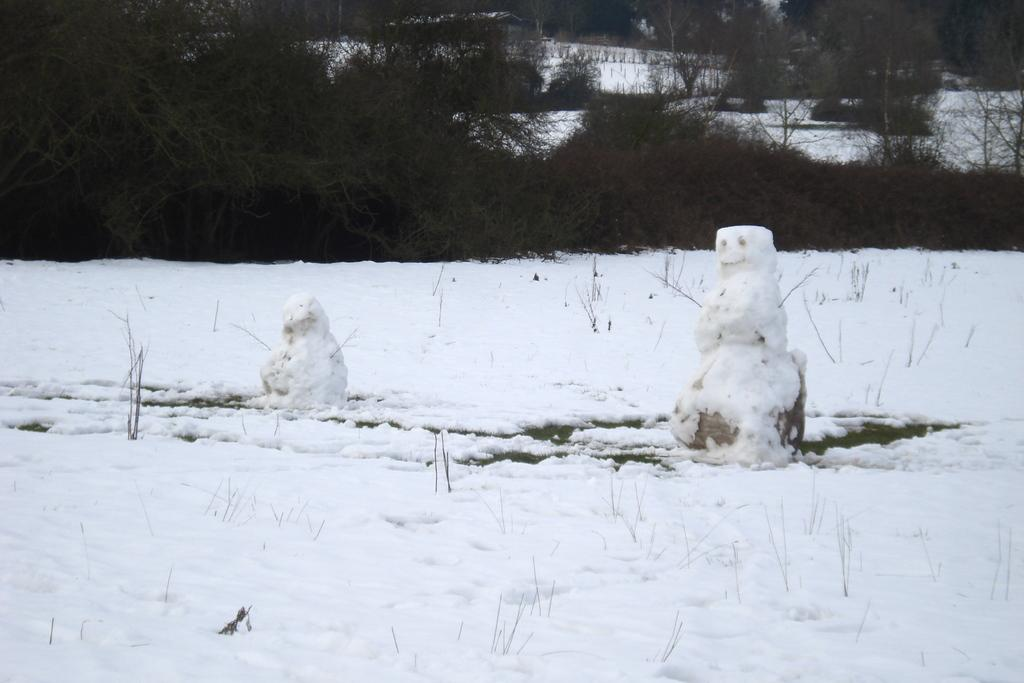What is present at the bottom of the image? There is snow at the bottom of the image. What can be seen in the middle of the image? There are two snow dolls in the middle of the image. What is visible in the background of the image? There are trees in the background of the image. Can you see any planes flying over the snow in the image? There are no planes visible in the image; it only features snow, snow dolls, and trees. Is there a school visible in the background of the image? There is no school present in the image; it only features snow, snow dolls, and trees. 